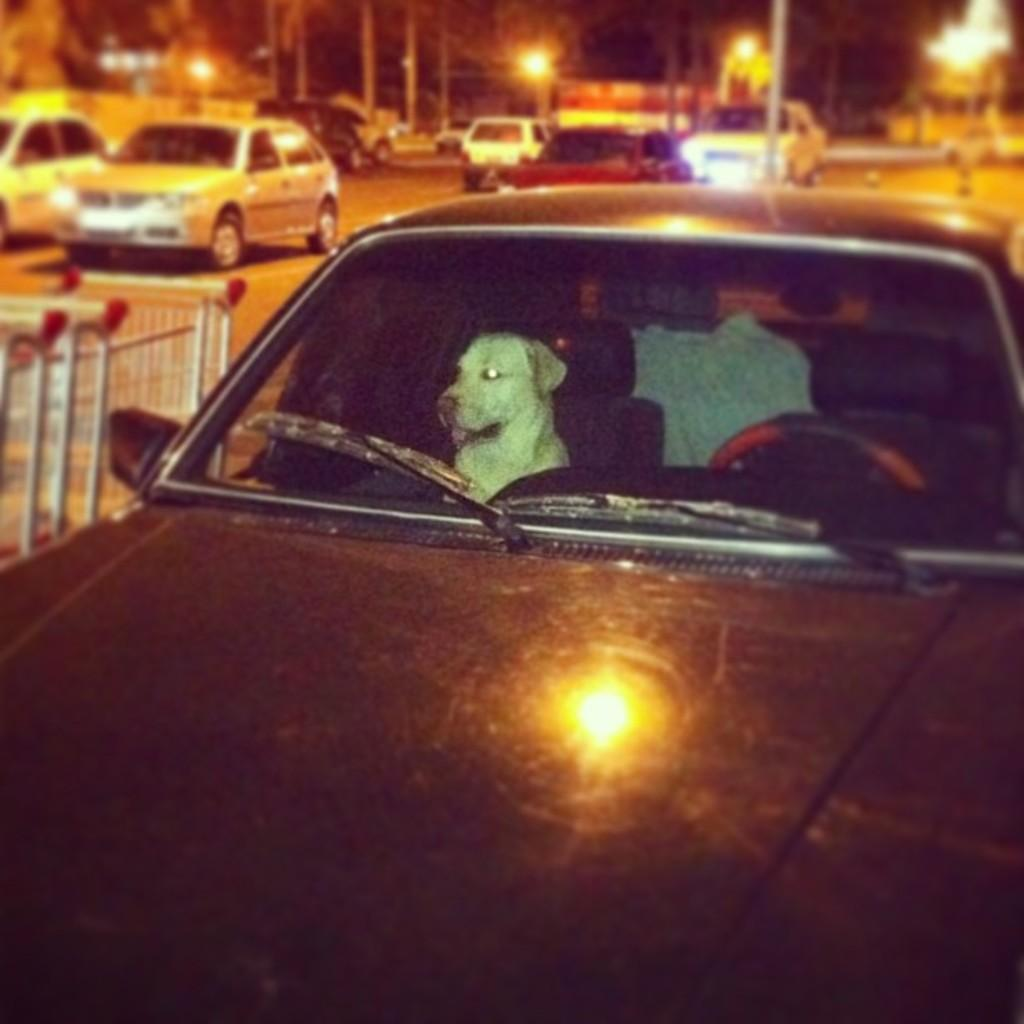What type of vehicle is in the image? There is a black car in the image. What is inside the car? There is a dog inside the car. What can be seen in the background of the image? There are other vehicles, light poles, and trees in the background of the image. What type of jar is being used as a weapon by the dog in the image? There is no jar present in the image, and the dog is not using any weapon. 